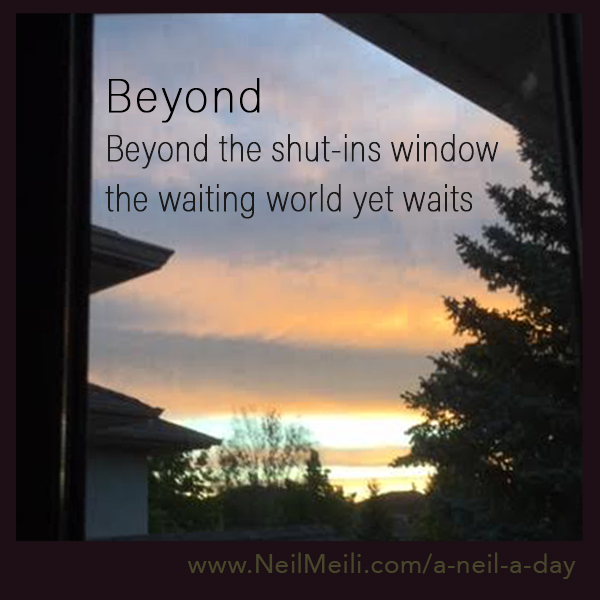Create a poetic piece inspired by the image. Beyond the pane, the sky ignites,
In hues of gold and soft twilight.
A world unseen, a realm of light,
Awaits the heart in silent flight.
The trees, they whisper tales untold,
Of dreams fulfilled and hopes retold.
Within this frame, the soul is bold,
To venture out and break the mold. 